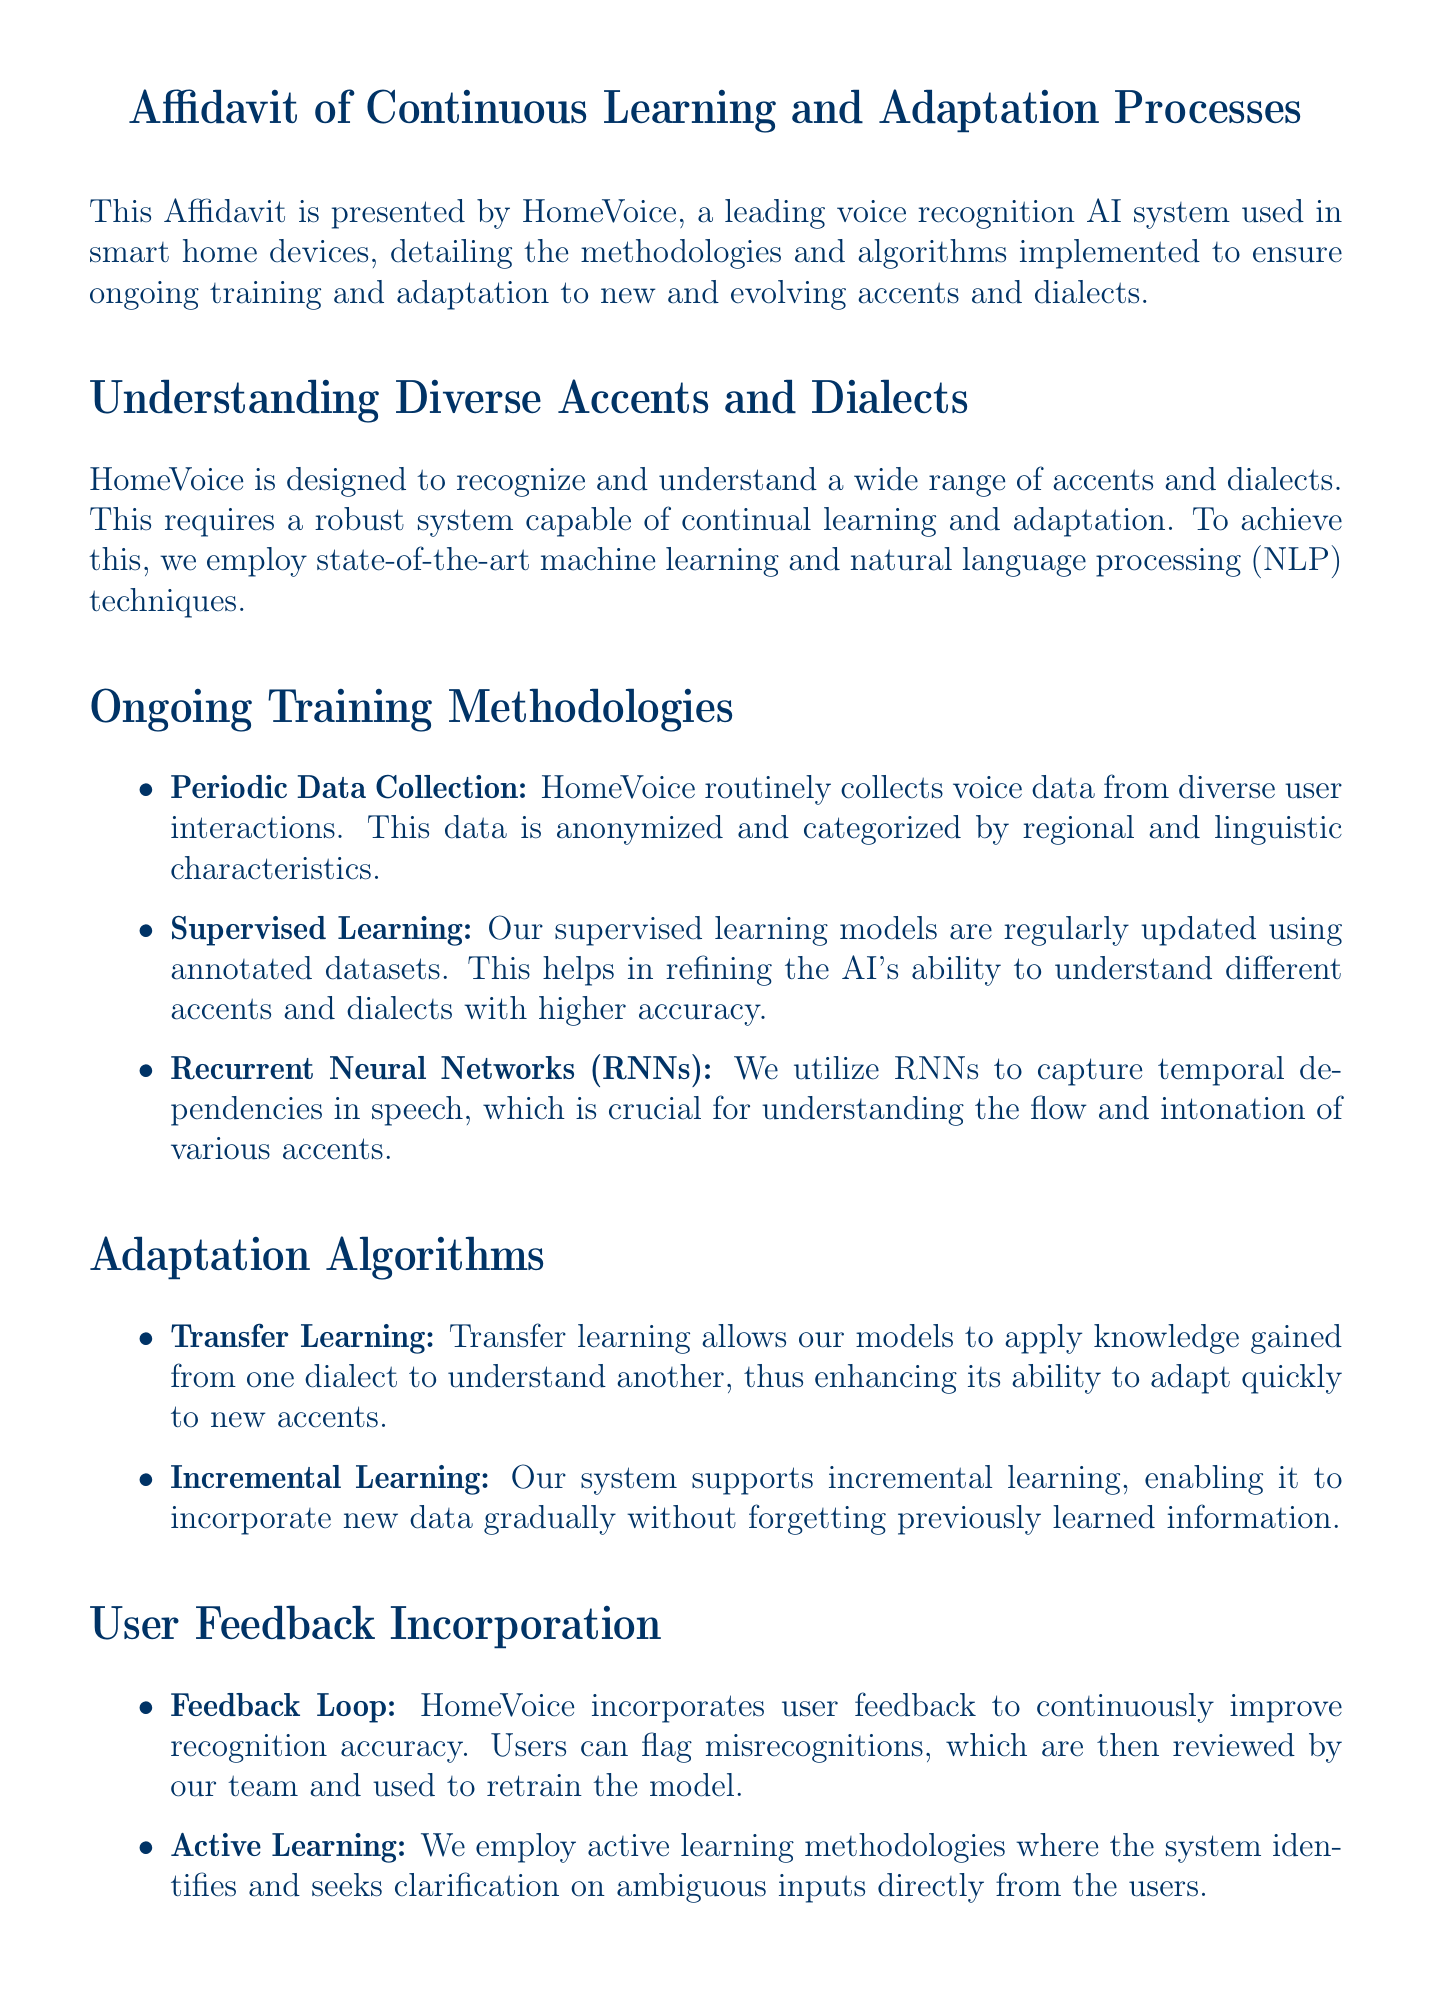What is the name of the AI system? The document specifies "HomeVoice" as the voice recognition AI system.
Answer: HomeVoice Who presented the affidavit? The affidavit is presented by HomeVoice, a leading voice recognition AI system.
Answer: HomeVoice What date was the affidavit signed? The document mentions the signing date as "2023-10-15."
Answer: 2023-10-15 What type of learning models does HomeVoice use? The document states that HomeVoice employs "supervised learning" models regularly updated.
Answer: supervised learning What algorithm allows knowledge transfer between dialects? The affidavit mentions "transfer learning" as the algorithm used.
Answer: transfer learning Which neural network type is used to capture temporal dependencies? The document states that "Recurrent Neural Networks (RNNs)" are used for this purpose.
Answer: Recurrent Neural Networks (RNNs) What is the purpose of the feedback loop mentioned in the document? The feedback loop helps in improving recognition accuracy by using user feedback.
Answer: improve recognition accuracy What methodology seeks clarification from users on ambiguous inputs? The document describes "active learning" as the methodology employed.
Answer: active learning Who is the Chief AI Scientist mentioned in the document? The signed affidavit includes "Dr. Jane Smith" as the Chief AI Scientist.
Answer: Dr. Jane Smith 